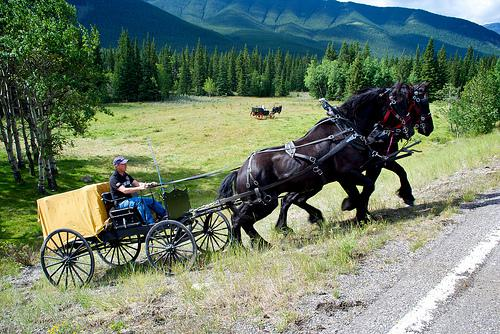Question: where was the picture taken?
Choices:
A. At a zoo.
B. In a field.
C. In a car.
D. On a bridge.
Answer with the letter. Answer: B Question: how many horses are there?
Choices:
A. 6.
B. 5.
C. 2.
D. 3.
Answer with the letter. Answer: C Question: what color are the horses?
Choices:
A. Brown.
B. Black.
C. White.
D. Grey.
Answer with the letter. Answer: B Question: why was the picture taken?
Choices:
A. To capture her playing.
B. To remember the party.
C. To show the man riding.
D. To show the new paint.
Answer with the letter. Answer: C 